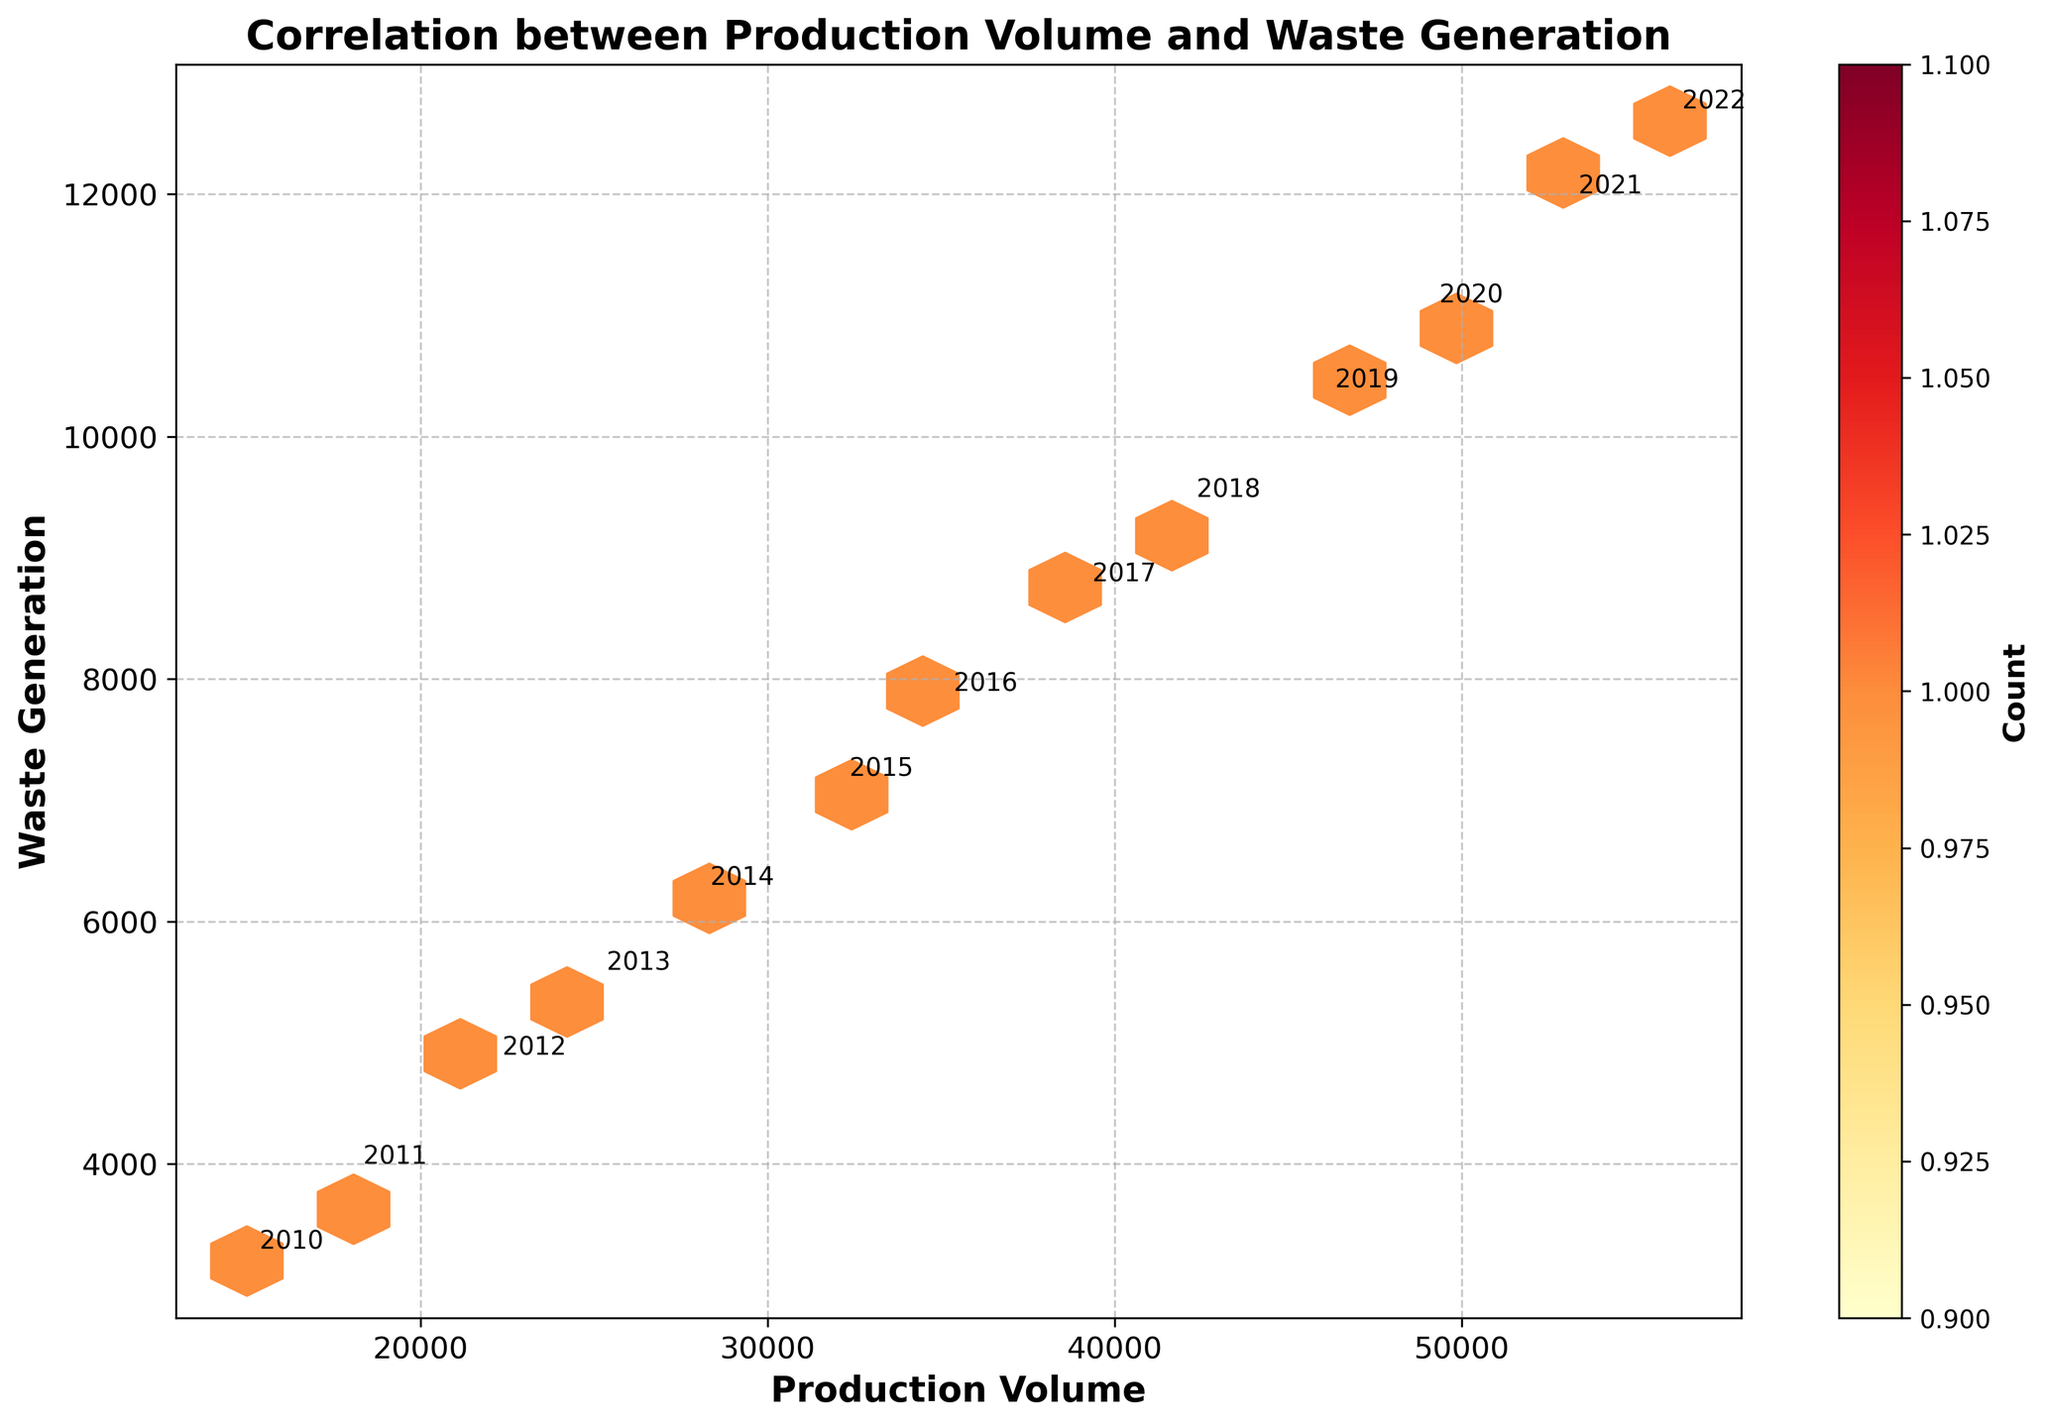What is the title of the plot? The title of the plot is always displayed at the top of the figure. In this case, it is labeled as "Correlation between Production Volume and Waste Generation."
Answer: Correlation between Production Volume and Waste Generation What's the color range used in the plot? By looking at the plot, we can identify that the color range goes from a lighter yellow to a darker red. This spectrum indicates the density of data points in each hexbin.
Answer: Yellow to Red How many hexbin data points are there? Counting the hexagonal bins in the plot will give us the number of hexbin data points. It can be tricky since the plot uses a color gradient, but each hexbin represents a data point cluster.
Answer: 13 What years have the highest production volume and waste generation? The year labels annotated on the plot next to the highest production volume and waste generation data points will provide this information. By visually inspecting these annotations, we can find that 2022 has the highest values.
Answer: 2022 Which year had a production volume of 25,000? By looking for the annotation near the production volume of 25,000 on the x-axis, we can determine that the year 2013 is associated with this data point.
Answer: 2013 What is the correlation between production volume and waste generation? The general trend of the hexbin plot shows that as production volume increases along the x-axis, waste generation also increases along the y-axis, indicating a positive correlation.
Answer: Positive What is the impact on waste generation as production volume increases from 15,000 to 56,000? By looking at the range from 15,000 to 56,000 on the x-axis and tracking the corresponding y-axis values, we see that waste generation increases from 3,200 to 12,600. This shows a steep increase in waste generation with production volume.
Answer: Increase Which year had the lowest waste generation? The lowest point on the y-axis that has a year annotation will indicate the earliest year in the data, which is 2010.
Answer: 2010 Do data points cluster more in the lower, middle, or higher range of production volume? The color density of the hexagonal bins can show this clustering. Most of the hexbin colors are concentrated in the middle to higher range, indicating data clustering in these ranges.
Answer: Middle to Higher Range What year is annotated closest to the hexbin with the highest density (darkest red)? The darkest red hexbin indicates the highest density of overlapping data points. The year annotation closest to this hexbin is 2022, showing significant production and waste.
Answer: 2022 